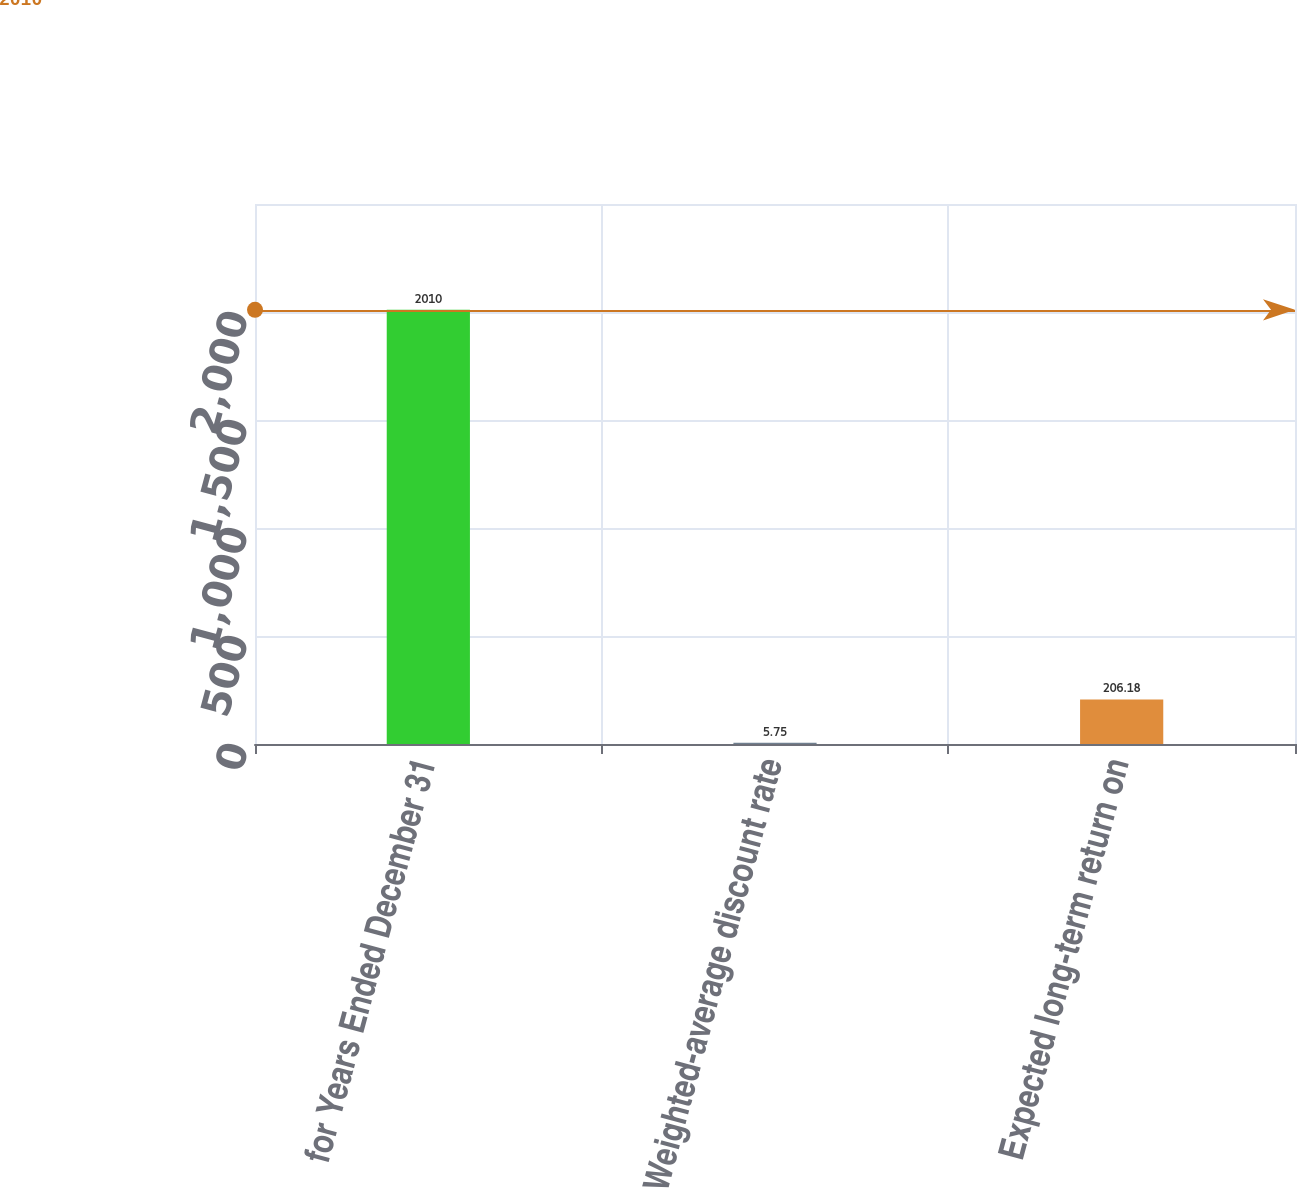Convert chart to OTSL. <chart><loc_0><loc_0><loc_500><loc_500><bar_chart><fcel>for Years Ended December 31<fcel>Weighted-average discount rate<fcel>Expected long-term return on<nl><fcel>2010<fcel>5.75<fcel>206.18<nl></chart> 